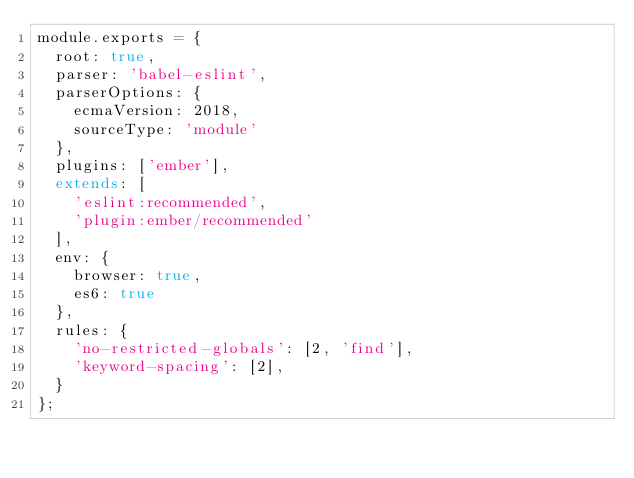Convert code to text. <code><loc_0><loc_0><loc_500><loc_500><_JavaScript_>module.exports = {
  root: true,
  parser: 'babel-eslint',
  parserOptions: {
    ecmaVersion: 2018,
    sourceType: 'module'
  },
  plugins: ['ember'],
  extends: [
    'eslint:recommended',
    'plugin:ember/recommended'
  ],
  env: {
    browser: true,
    es6: true
  },
  rules: {
    'no-restricted-globals': [2, 'find'],
    'keyword-spacing': [2],
  }
};
</code> 